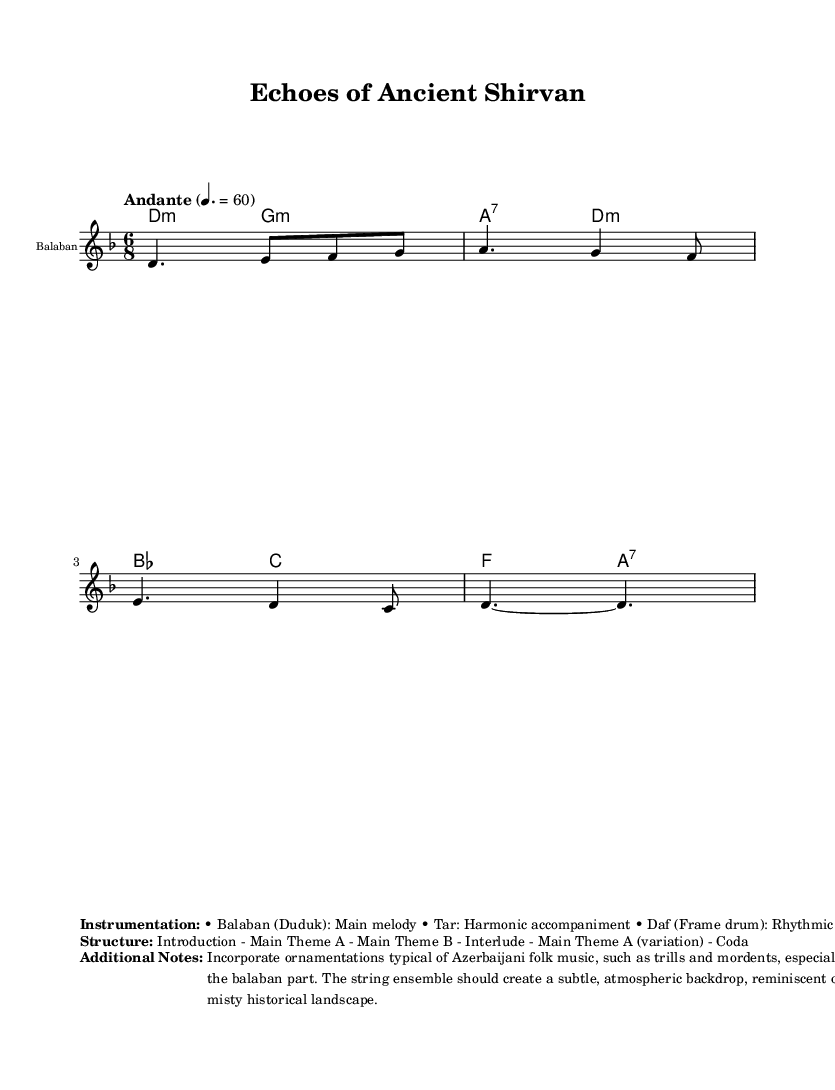What is the key signature of this music? The key signature is indicated with sharp or flat symbols at the beginning of the staff. In this sheet music, it shows a 'D' and a flat symbol, indicating D minor.
Answer: D minor What is the time signature of the piece? The time signature is shown as a fraction at the beginning of the staff. Here, it is shown as '6/8', indicating a compound duple meter.
Answer: 6/8 What is the tempo marking? The tempo marking is indicated at the start of the piece with a description written alongside a metronome marking. Here, it states "Andante" with a metronome marking of 60.
Answer: Andante 60 What is the main instrument featured in the melody? The main instrument is identified in the staff header where it specifies "Balaban." This instrument plays the main melody line throughout the piece.
Answer: Balaban How many main themes are presented in the structure of the piece? The structure section outlines the organization of the composition. It lists "Main Theme A" and "Main Theme B" separately, indicating that there are two main themes.
Answer: 2 What type of ornamentations are suggested for the balaban part? The additional notes specify the types of ornamentations to be incorporated into the music. It details that trills and mordents should be used in the balaban part.
Answer: Trills and mordents What type of accompaniment is indicated for the rhythm section? The instrumentation section mentions the 'Daf' as the frame drum that provides the rhythmic accompaniment to the piece.
Answer: Daf 